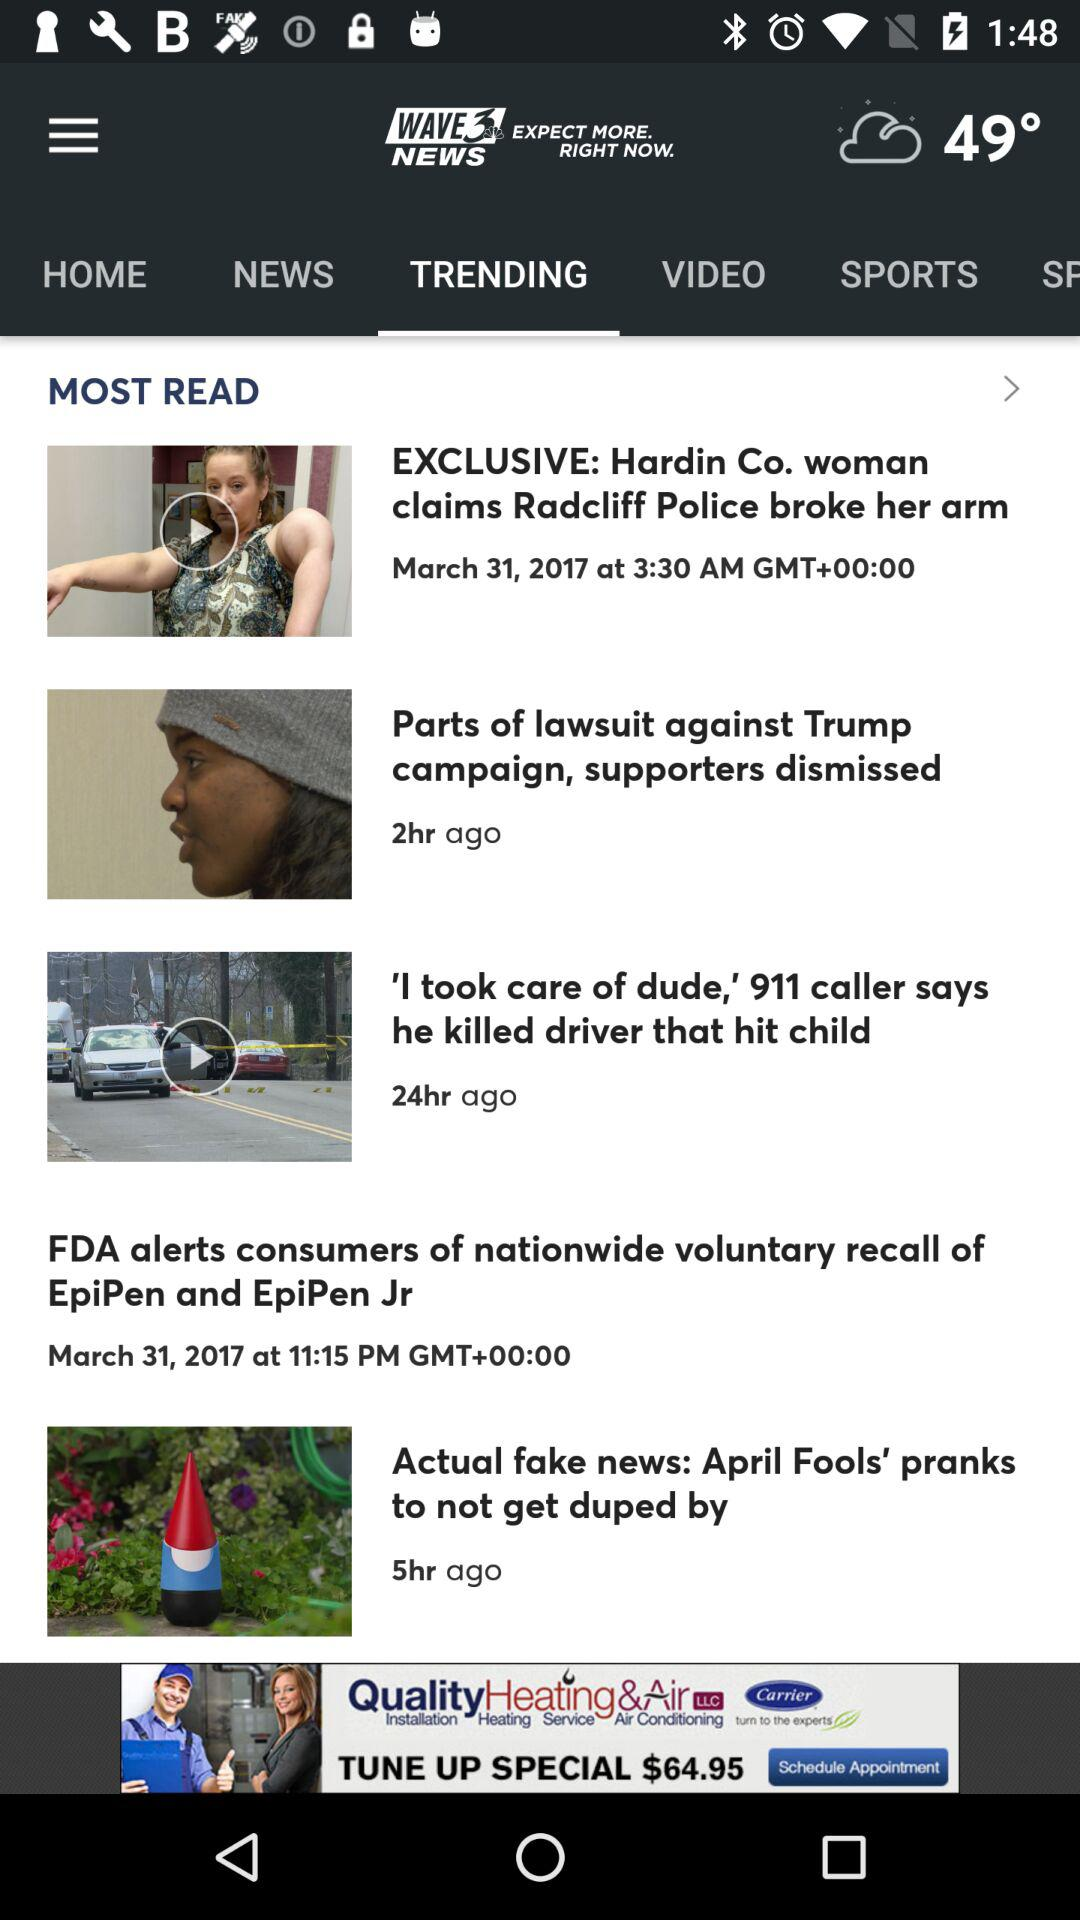Which news was posted 24 hours ago? The news was "'I took care of dude,' 911 caller says he killed driver that hit child". 